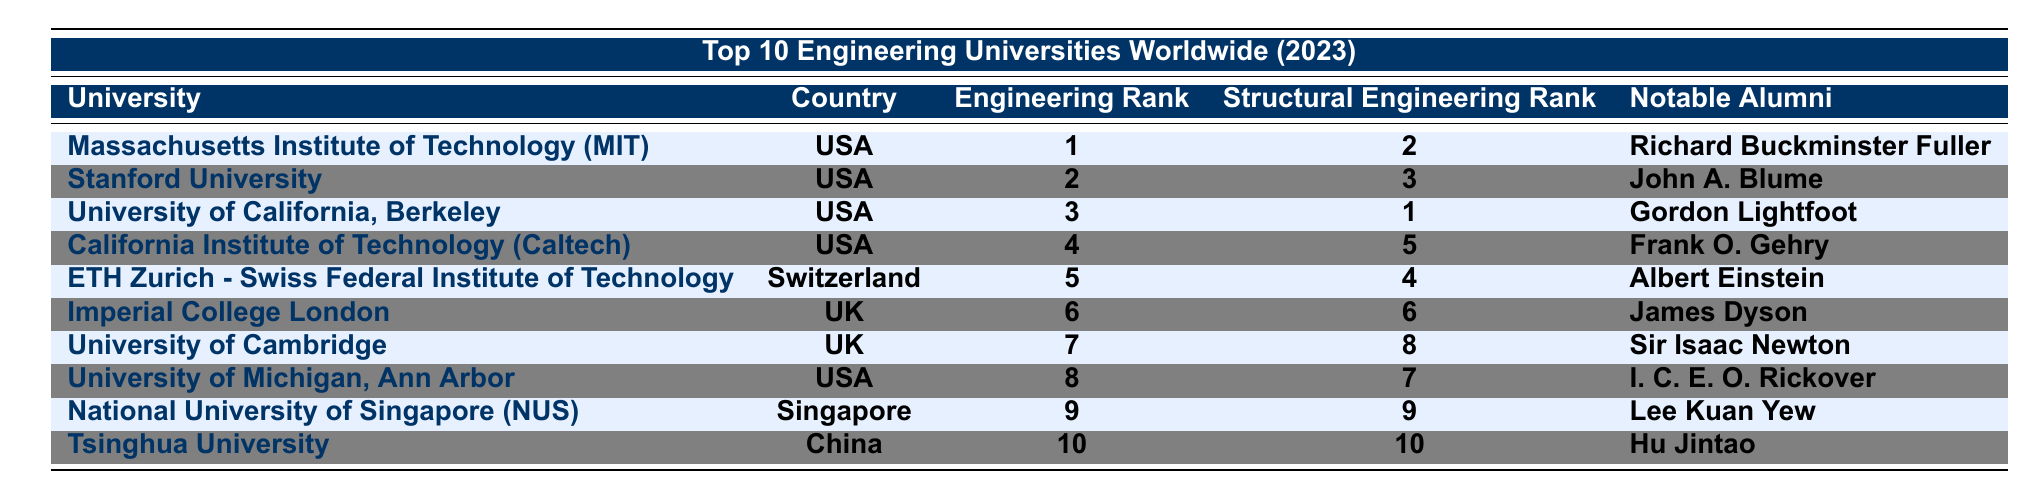What university has the highest engineering rank? The table shows that the Massachusetts Institute of Technology (MIT) has the highest engineering rank, which is 1.
Answer: Massachusetts Institute of Technology (MIT) Which country has the university ranked first in structural engineering? According to the table, the University of California, Berkeley, which is in the USA, is ranked first in structural engineering.
Answer: USA Is the University of Cambridge ranked higher in engineering or structural engineering? The University of Cambridge has an engineering rank of 7 and a structural engineering rank of 8. Since 7 is higher than 8, it is ranked higher in engineering.
Answer: Higher in engineering What is the rank difference between the top university in engineering and the university ranked sixth? The top university, MIT, has an engineering rank of 1, and Imperial College London, ranked sixth, has a rank of 6. The difference is 6 - 1 = 5.
Answer: 5 Which university is tied for the same rank in both engineering and structural engineering? The National University of Singapore (NUS) is ranked 9 in both engineering and structural engineering, indicating a tie.
Answer: National University of Singapore (NUS) How many universities from the USA are in the top 5 for engineering? The table lists 4 universities from the USA in the top 5: MIT, Stanford, UC Berkeley, and Caltech.
Answer: 4 Are there any universities in the table that are ranked first in structural engineering? Yes, the University of California, Berkeley is ranked first in structural engineering according to the table.
Answer: Yes What is the notable alumni of California Institute of Technology? The table indicates that Frank O. Gehry is the notable alumni of California Institute of Technology.
Answer: Frank O. Gehry If we average the engineering ranks of the universities in the UK, what is the result? The engineering ranks for UK universities are 6 (Imperial College London) and 7 (University of Cambridge). The average is (6 + 7) / 2 = 6.5.
Answer: 6.5 Which university ranks higher in engineering: Tsinghua University or National University of Singapore? Tsinghua University has an engineering rank of 10, while the National University of Singapore has a rank of 9. Therefore, NUS ranks higher.
Answer: National University of Singapore What is the structural engineering rank of the university known for its notable alumni, Lee Kuan Yew? The notable alumni, Lee Kuan Yew, is from the National University of Singapore, which has a structural engineering rank of 9.
Answer: 9 